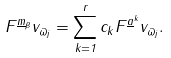Convert formula to latex. <formula><loc_0><loc_0><loc_500><loc_500>F ^ { \underline { m } _ { \beta } } v _ { \varpi _ { j } } = \sum _ { k = 1 } ^ { r } c _ { k } F ^ { \underline { a } ^ { k } } v _ { \varpi _ { j } } .</formula> 